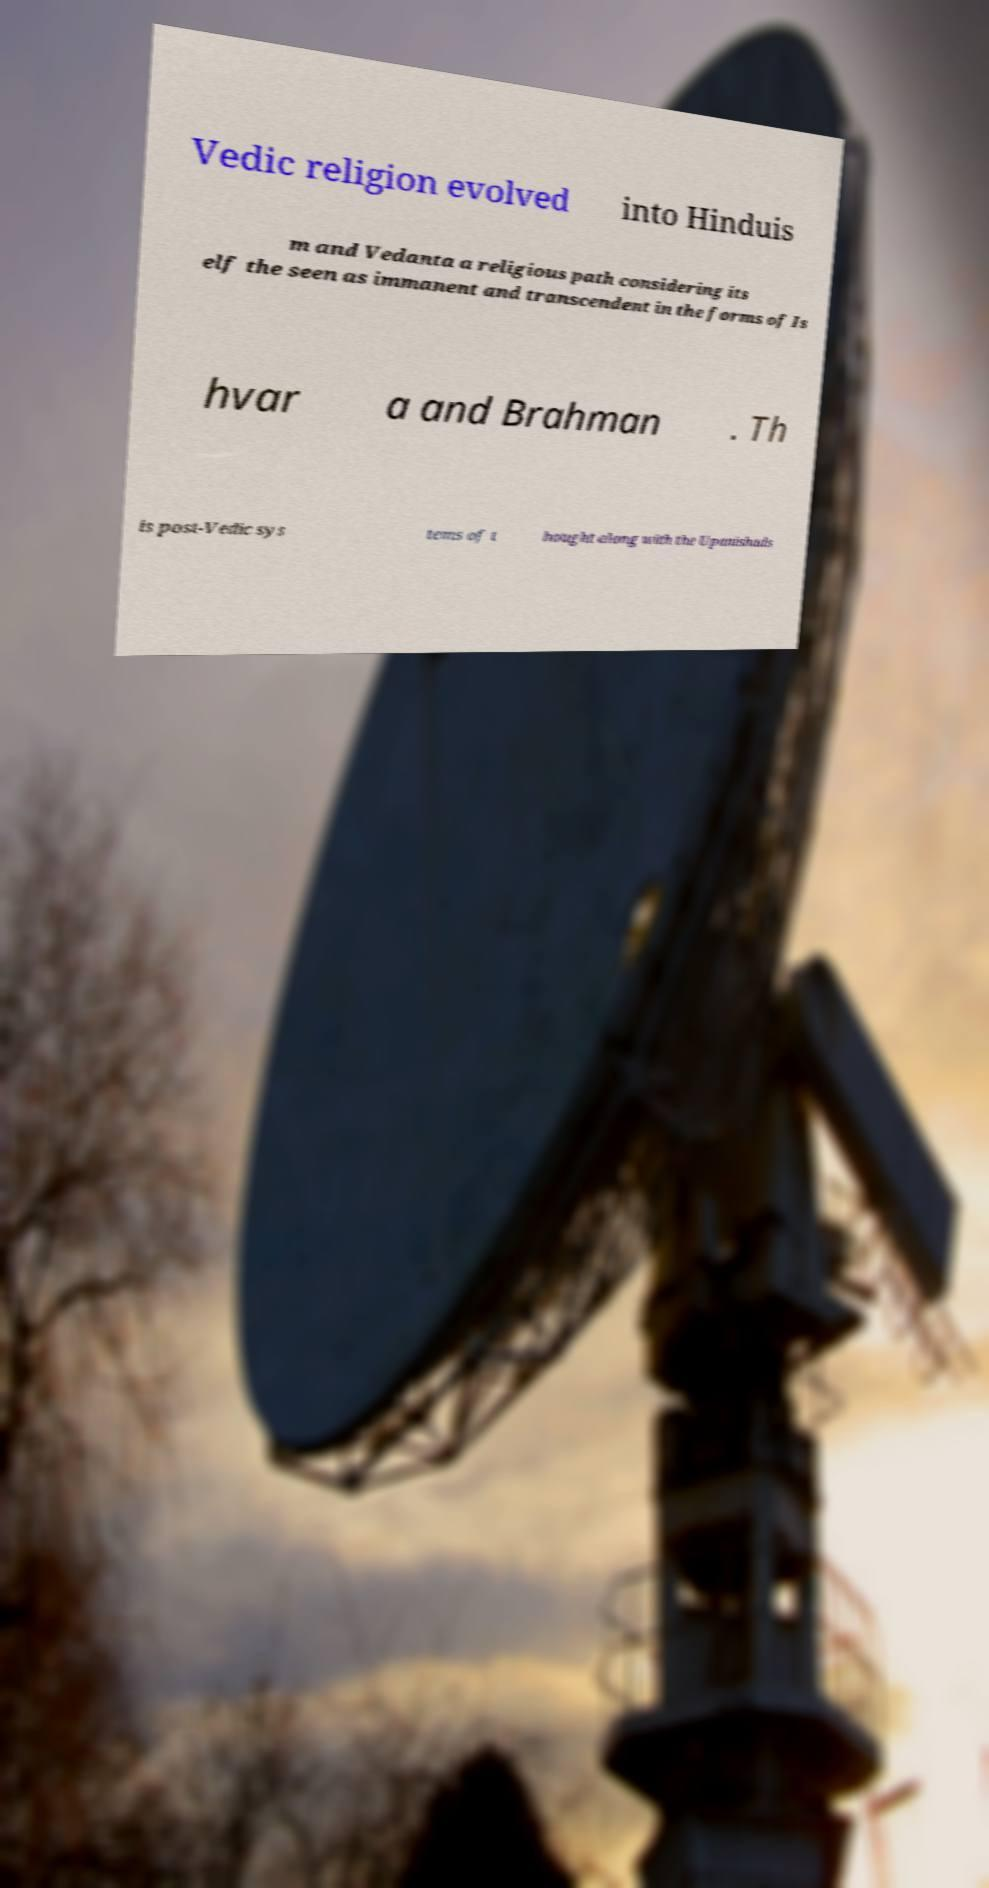Can you read and provide the text displayed in the image?This photo seems to have some interesting text. Can you extract and type it out for me? Vedic religion evolved into Hinduis m and Vedanta a religious path considering its elf the seen as immanent and transcendent in the forms of Is hvar a and Brahman . Th is post-Vedic sys tems of t hought along with the Upanishads 